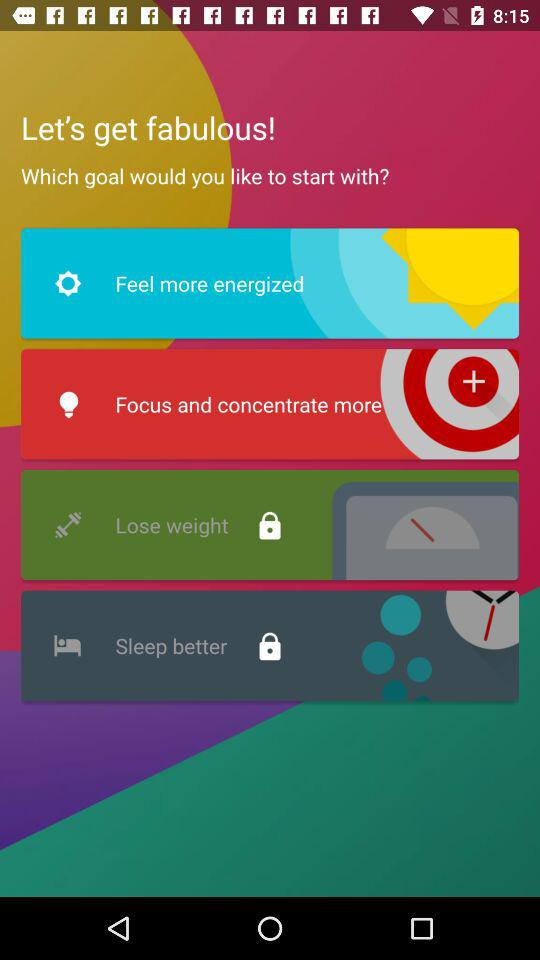How many goals are there?
Answer the question using a single word or phrase. 4 